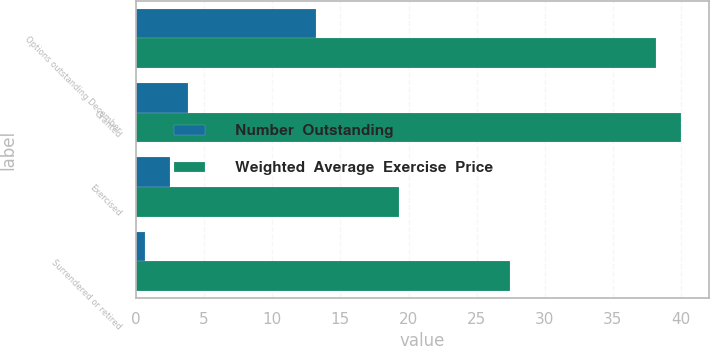<chart> <loc_0><loc_0><loc_500><loc_500><stacked_bar_chart><ecel><fcel>Options outstanding December<fcel>Granted<fcel>Exercised<fcel>Surrendered or retired<nl><fcel>Number  Outstanding<fcel>13.2<fcel>3.8<fcel>2.5<fcel>0.7<nl><fcel>Weighted  Average  Exercise  Price<fcel>38.15<fcel>40.01<fcel>19.31<fcel>27.43<nl></chart> 